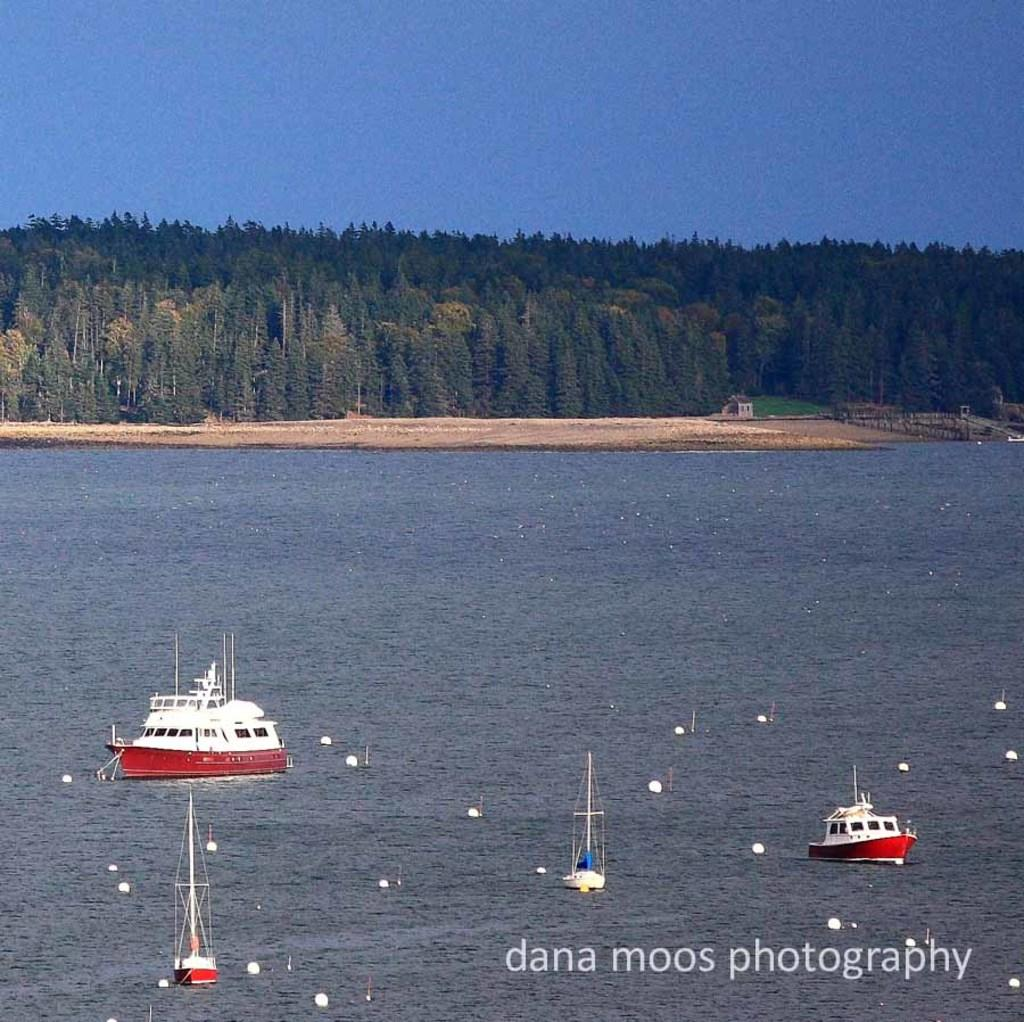What is happening in the image? There are ships sailing on the water in the image. What can be seen in the background of the image? There are trees visible in the image. Can you see the son of the ship's captain in the image? There is no mention of a son or a ship's captain in the image, so we cannot determine if the son is present. 